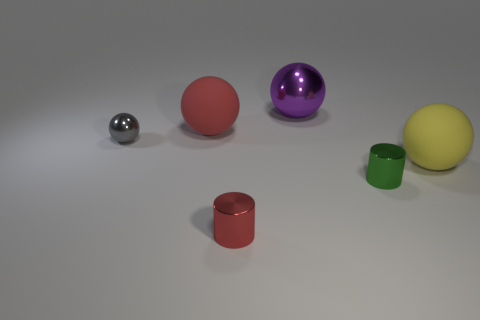Subtract all gray cylinders. Subtract all red balls. How many cylinders are left? 2 Add 2 small red metallic cylinders. How many objects exist? 8 Subtract all cylinders. How many objects are left? 4 Subtract all big rubber things. Subtract all tiny red things. How many objects are left? 3 Add 3 big yellow balls. How many big yellow balls are left? 4 Add 2 large yellow things. How many large yellow things exist? 3 Subtract 0 red cubes. How many objects are left? 6 